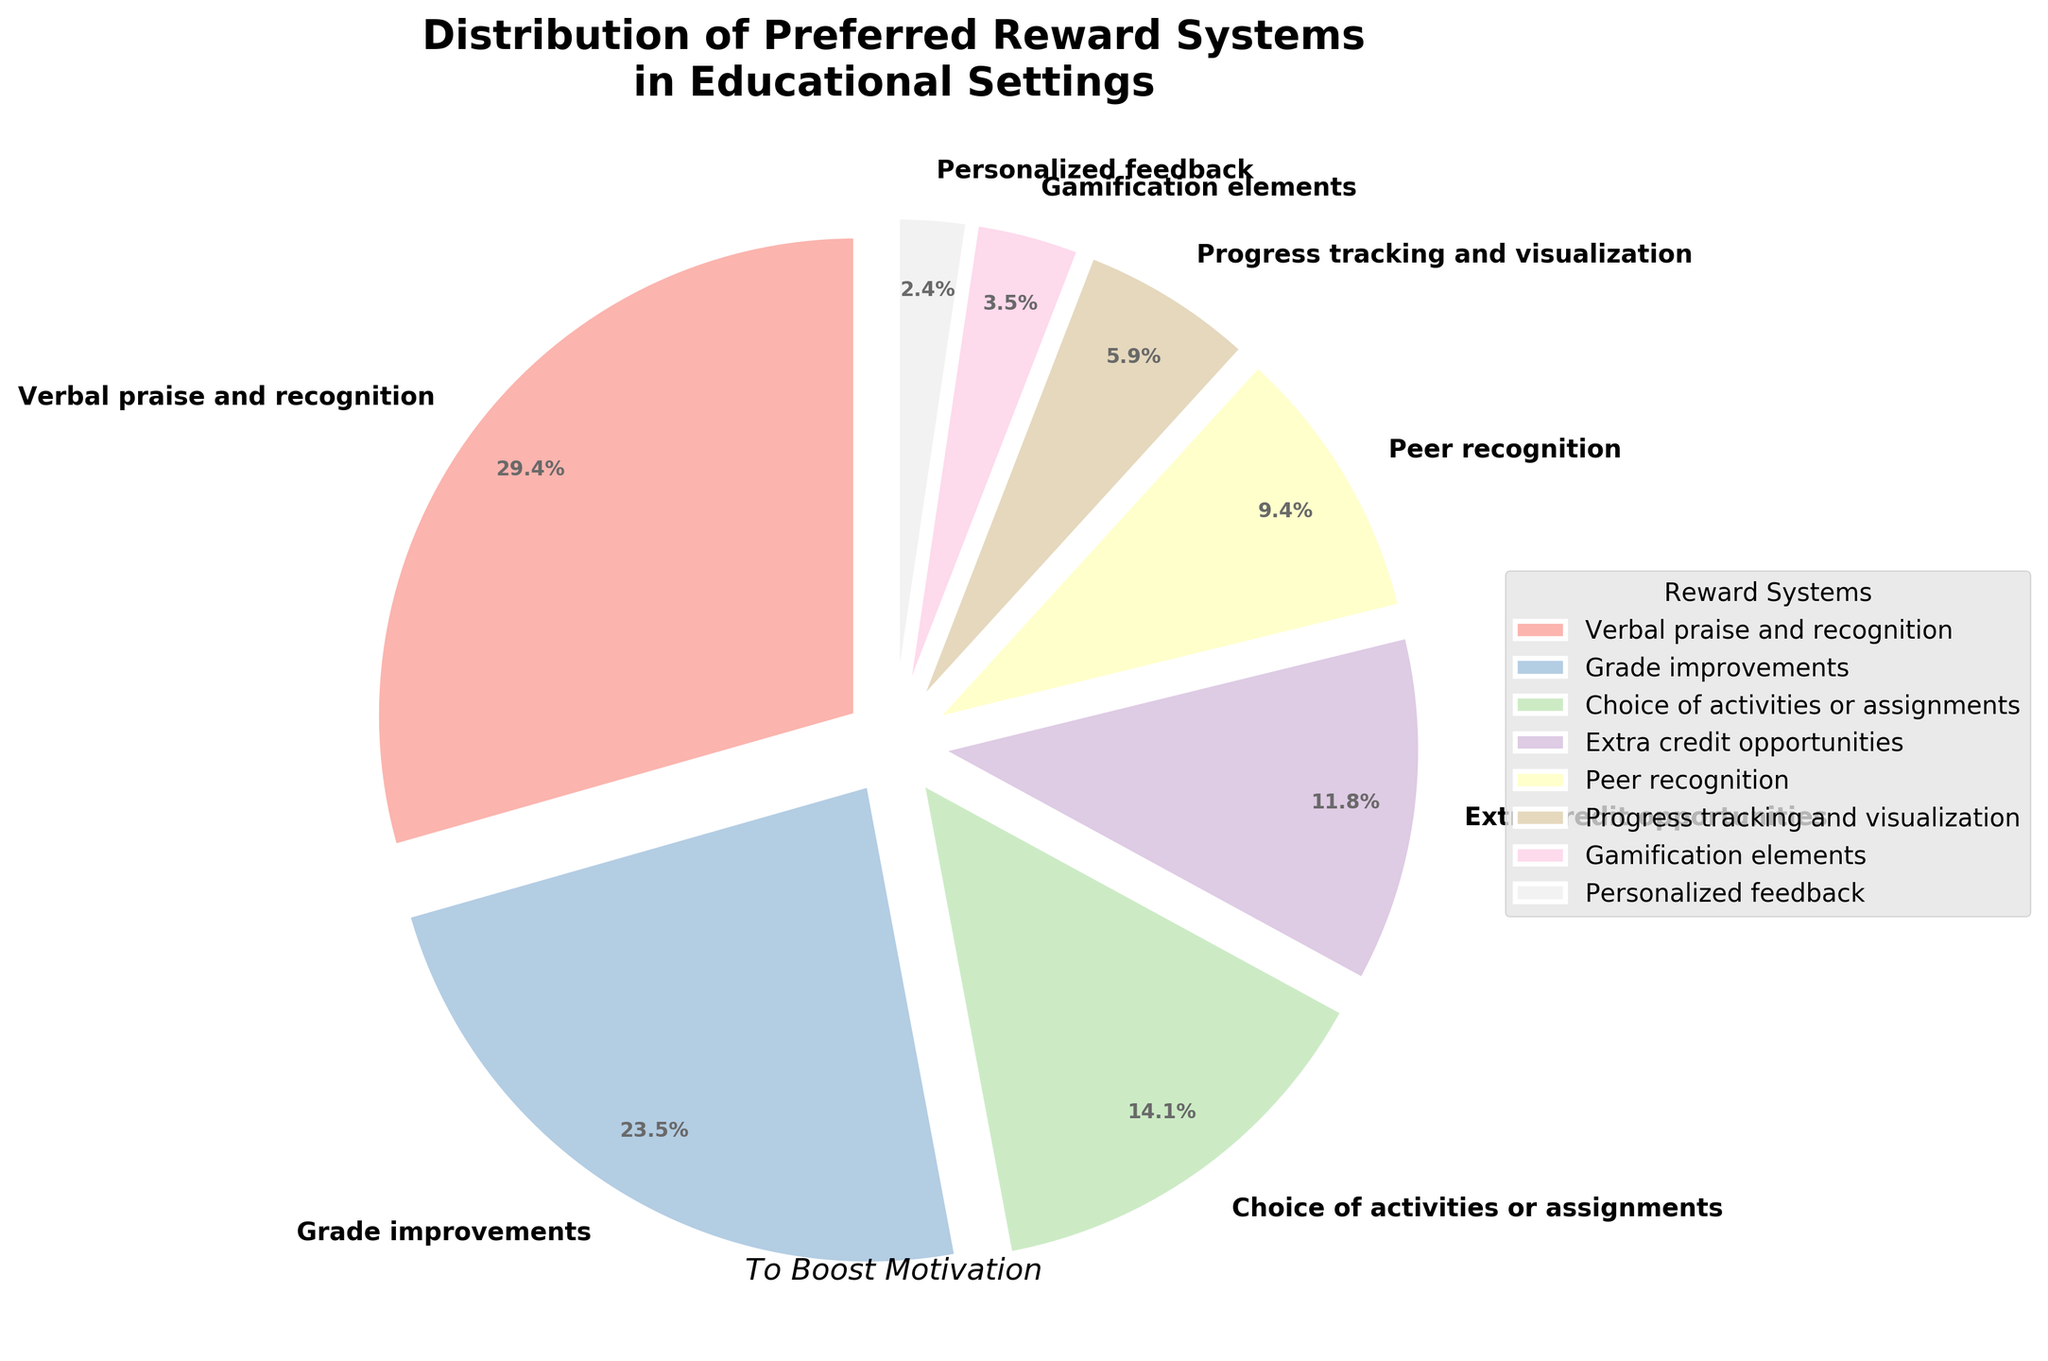which reward system is the most preferred? The largest wedge in the pie chart represents the most preferred reward system. It accounts for 25% of the total and is labeled "Verbal praise and recognition."
Answer: Verbal praise and recognition what is the combined preference percentage for "Extra credit opportunities" and "Peer recognition"? To find the combined preference percentage, add the percentages for "Extra credit opportunities" (10%) and "Peer recognition" (8%). This results in 10% + 8% = 18%.
Answer: 18% which two reward systems have the smallest preference percentages? The smallest wedges in the pie chart represent the least preferred reward systems. The two smallest wedges are "Personalized feedback" with 2% and "Gamification elements" with 3%.
Answer: Personalized feedback and Gamification elements is "Choice of activities or assignments" more preferred than "Progress tracking and visualization"? Compare the percentages of the two reward systems. "Choice of activities or assignments" has 12%, while "Progress tracking and visualization" has 5%. Since 12% > 5%, "Choice of activities or assignments" is more preferred.
Answer: Yes which four reward systems together make up more than half of the preferences? Identify the wedges that together make up more than 50%. The four largest wedges are "Verbal praise and recognition" (25%), "Grade improvements" (20%), "Choice of activities or assignments" (12%), and "Extra credit opportunities" (10%). Their combined total is 25% + 20% + 12% + 10% = 67%, which is more than half.
Answer: Verbal praise and recognition, Grade improvements, Choice of activities or assignments, Extra credit opportunities how much more preferred is "Verbal praise and recognition" than "Grade improvements"? Subtract the percentage for "Grade improvements" from the percentage for "Verbal praise and recognition". This results in 25% - 20% = 5%.
Answer: 5% if you combined the least three preferred reward systems, what would their total percentage be? The least three preferred reward systems are "Gamification elements" (3%), "Personalized feedback" (2%), and "Progress tracking and visualization" (5%). Their combined total is 3% + 2% + 5% = 10%.
Answer: 10% which reward system has a similar preference percentage to "Grade improvements"? Find a reward system with a percentage close to that of "Grade improvements" (20%). "Verbal praise and recognition" has a percentage of 25%, which is the closest to 20%.
Answer: Verbal praise and recognition what percentage of the preferences is made up by reward systems excluding the top two preferred ones? Exclude the top two preferred reward systems ("Verbal praise and recognition" at 25% and "Grade improvements" at 20%). The remaining reward systems make up 100% - (25% + 20%) = 100% - 45% = 55%.
Answer: 55% which reward system appears to have the largest wedge with vibrant colors? The largest wedge with vibrant colors is likely the one representing "Verbal praise and recognition" as it has the largest area in the pie chart and the pastel color palette makes it stand out.
Answer: Verbal praise and recognition 